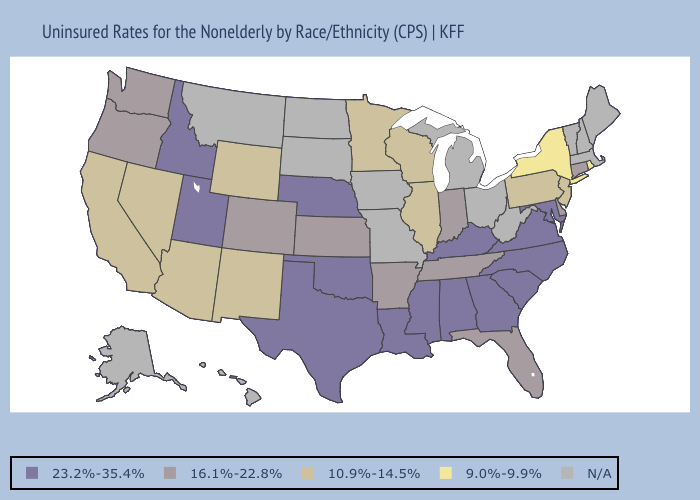Name the states that have a value in the range N/A?
Concise answer only. Alaska, Hawaii, Iowa, Maine, Massachusetts, Michigan, Missouri, Montana, New Hampshire, North Dakota, Ohio, South Dakota, Vermont, West Virginia. Does Nevada have the lowest value in the West?
Give a very brief answer. Yes. Name the states that have a value in the range 9.0%-9.9%?
Be succinct. New York, Rhode Island. Does Nebraska have the highest value in the MidWest?
Short answer required. Yes. Which states have the highest value in the USA?
Write a very short answer. Alabama, Georgia, Idaho, Kentucky, Louisiana, Maryland, Mississippi, Nebraska, North Carolina, Oklahoma, South Carolina, Texas, Utah, Virginia. Among the states that border Louisiana , does Arkansas have the highest value?
Keep it brief. No. What is the lowest value in the Northeast?
Keep it brief. 9.0%-9.9%. What is the highest value in the USA?
Answer briefly. 23.2%-35.4%. How many symbols are there in the legend?
Quick response, please. 5. What is the highest value in states that border West Virginia?
Give a very brief answer. 23.2%-35.4%. Does Delaware have the lowest value in the South?
Short answer required. Yes. What is the value of Illinois?
Keep it brief. 10.9%-14.5%. Name the states that have a value in the range N/A?
Quick response, please. Alaska, Hawaii, Iowa, Maine, Massachusetts, Michigan, Missouri, Montana, New Hampshire, North Dakota, Ohio, South Dakota, Vermont, West Virginia. What is the value of Massachusetts?
Give a very brief answer. N/A. 